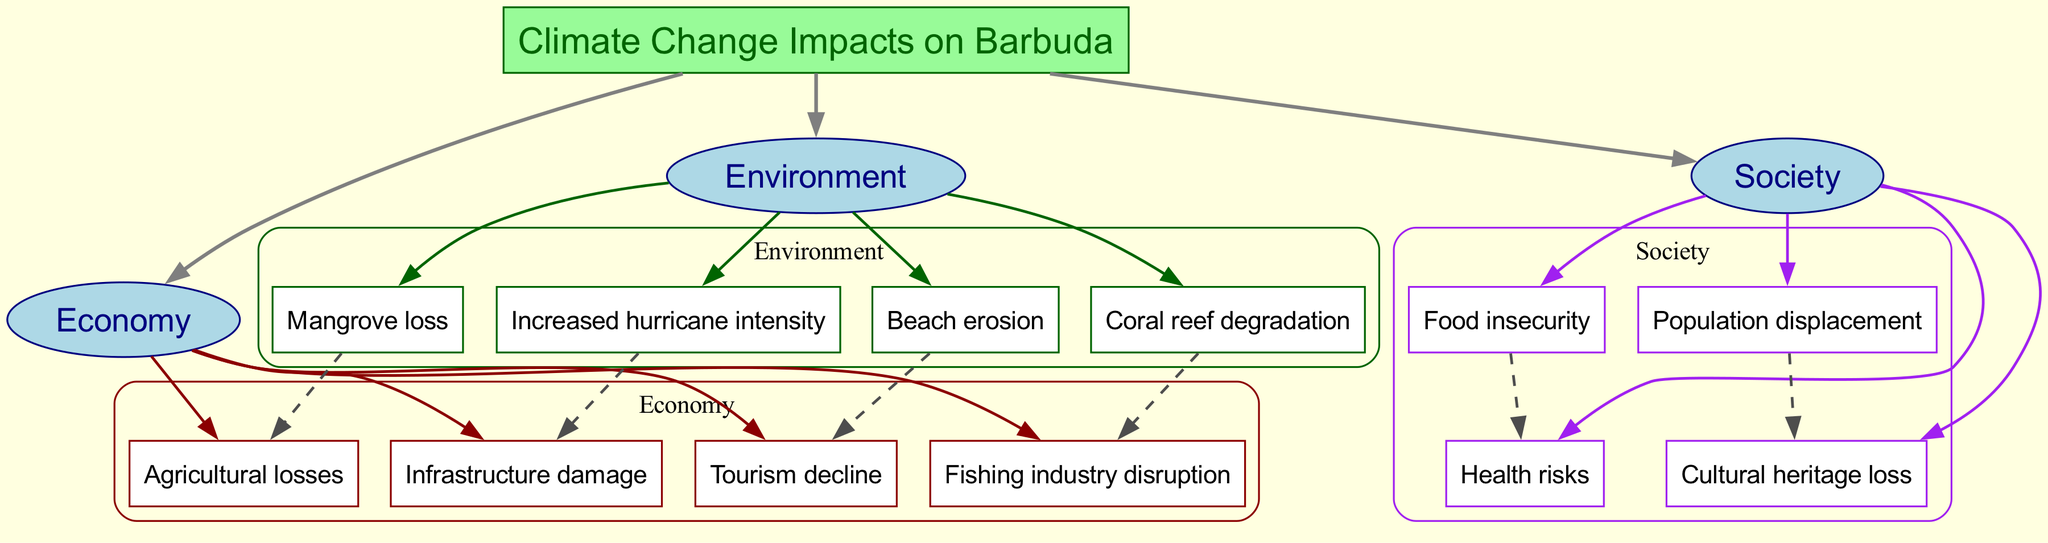What are the main categories impacted by climate change on Barbuda? The diagram lists three main categories: Economy, Environment, and Society. These categories are directly linked to the central node "Climate Change Impacts on Barbuda."
Answer: Economy, Environment, Society How many subcategories are listed under the Economy category? The Economy category contains four subcategories: Tourism decline, Fishing industry disruption, Agricultural losses, and Infrastructure damage. Therefore, the total number is counted directly from the nodes listed under this category.
Answer: Four What connection exists between coral reef degradation and the fishing industry? The diagram indicates that coral reef degradation leads to fishing industry disruption, as shown by an edge connecting these two nodes. This means that a negative impact on coral reefs affects the fishing industry directly.
Answer: Fishing industry disruption Which subcategory under Society is directly related to population displacement? The diagram shows a direct connection from Population displacement to Cultural heritage loss, indicating that population displacement causes cultural heritage loss. This is deduced through the explicit edge linking these two nodes.
Answer: Cultural heritage loss What is the relationship between food insecurity and health risks? The diagram illustrates that food insecurity leads to health risks, indicated by an edge connecting these two nodes. This implies that inadequate food supplies have consequences for health within the society.
Answer: Health risks How many total nodes are present in the diagram? The total number of nodes includes one central node, three main categories, four economy nodes, four environment nodes, and four society nodes for a total of sixteen nodes. By summing these counts, we arrive at the total number.
Answer: Sixteen What is the impact of mangrove loss in the Economy category? Mangrove loss is linked to Agricultural losses in the Economy category, meaning that the degradation of mangroves directly results in negative economic consequences, specifically impacting agricultural productivity.
Answer: Agricultural losses Which environmental node contributes to infrastructure damage due to climate change? The diagram connects Increased hurricane intensity to Infrastructure damage, suggesting that the severity of hurricanes directly leads to damage in the infrastructure. This relationship indicates a direct causation effect.
Answer: Infrastructure damage 